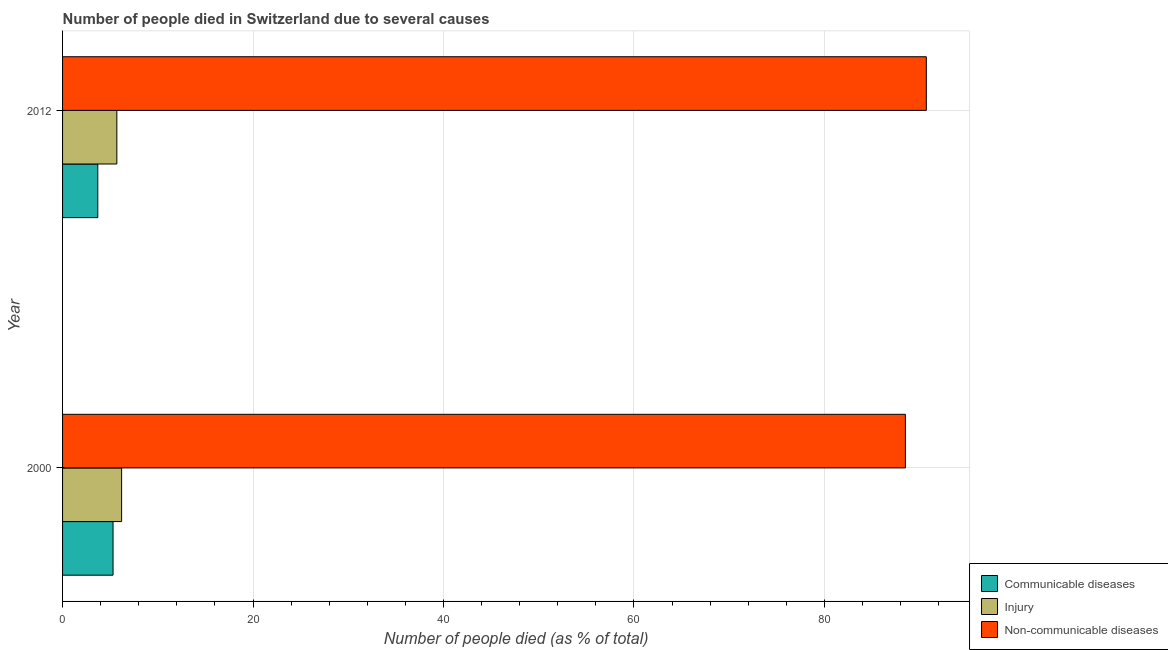How many groups of bars are there?
Provide a succinct answer. 2. How many bars are there on the 2nd tick from the bottom?
Provide a short and direct response. 3. What is the label of the 2nd group of bars from the top?
Offer a very short reply. 2000. Across all years, what is the maximum number of people who dies of non-communicable diseases?
Give a very brief answer. 90.7. Across all years, what is the minimum number of people who dies of non-communicable diseases?
Provide a succinct answer. 88.5. What is the total number of people who dies of non-communicable diseases in the graph?
Give a very brief answer. 179.2. What is the difference between the number of people who dies of non-communicable diseases in 2000 and the number of people who died of communicable diseases in 2012?
Give a very brief answer. 84.8. What is the average number of people who dies of non-communicable diseases per year?
Your response must be concise. 89.6. In the year 2012, what is the difference between the number of people who died of injury and number of people who dies of non-communicable diseases?
Your answer should be very brief. -85. In how many years, is the number of people who died of injury greater than 52 %?
Provide a succinct answer. 0. What is the ratio of the number of people who dies of non-communicable diseases in 2000 to that in 2012?
Offer a terse response. 0.98. What does the 1st bar from the top in 2012 represents?
Offer a very short reply. Non-communicable diseases. What does the 2nd bar from the bottom in 2000 represents?
Keep it short and to the point. Injury. Is it the case that in every year, the sum of the number of people who died of communicable diseases and number of people who died of injury is greater than the number of people who dies of non-communicable diseases?
Provide a short and direct response. No. How many bars are there?
Your answer should be compact. 6. Are all the bars in the graph horizontal?
Keep it short and to the point. Yes. How many years are there in the graph?
Provide a short and direct response. 2. What is the difference between two consecutive major ticks on the X-axis?
Offer a terse response. 20. Does the graph contain any zero values?
Offer a very short reply. No. Does the graph contain grids?
Ensure brevity in your answer.  Yes. How many legend labels are there?
Your answer should be very brief. 3. What is the title of the graph?
Ensure brevity in your answer.  Number of people died in Switzerland due to several causes. Does "Social Protection and Labor" appear as one of the legend labels in the graph?
Your response must be concise. No. What is the label or title of the X-axis?
Your response must be concise. Number of people died (as % of total). What is the label or title of the Y-axis?
Ensure brevity in your answer.  Year. What is the Number of people died (as % of total) of Communicable diseases in 2000?
Provide a short and direct response. 5.3. What is the Number of people died (as % of total) in Injury in 2000?
Keep it short and to the point. 6.2. What is the Number of people died (as % of total) in Non-communicable diseases in 2000?
Provide a short and direct response. 88.5. What is the Number of people died (as % of total) in Communicable diseases in 2012?
Ensure brevity in your answer.  3.7. What is the Number of people died (as % of total) of Non-communicable diseases in 2012?
Provide a short and direct response. 90.7. Across all years, what is the maximum Number of people died (as % of total) in Injury?
Make the answer very short. 6.2. Across all years, what is the maximum Number of people died (as % of total) of Non-communicable diseases?
Provide a short and direct response. 90.7. Across all years, what is the minimum Number of people died (as % of total) of Communicable diseases?
Your answer should be very brief. 3.7. Across all years, what is the minimum Number of people died (as % of total) of Injury?
Ensure brevity in your answer.  5.7. Across all years, what is the minimum Number of people died (as % of total) of Non-communicable diseases?
Give a very brief answer. 88.5. What is the total Number of people died (as % of total) of Non-communicable diseases in the graph?
Your answer should be very brief. 179.2. What is the difference between the Number of people died (as % of total) of Communicable diseases in 2000 and that in 2012?
Make the answer very short. 1.6. What is the difference between the Number of people died (as % of total) in Injury in 2000 and that in 2012?
Offer a very short reply. 0.5. What is the difference between the Number of people died (as % of total) in Communicable diseases in 2000 and the Number of people died (as % of total) in Non-communicable diseases in 2012?
Make the answer very short. -85.4. What is the difference between the Number of people died (as % of total) of Injury in 2000 and the Number of people died (as % of total) of Non-communicable diseases in 2012?
Offer a terse response. -84.5. What is the average Number of people died (as % of total) of Communicable diseases per year?
Your response must be concise. 4.5. What is the average Number of people died (as % of total) of Injury per year?
Offer a very short reply. 5.95. What is the average Number of people died (as % of total) of Non-communicable diseases per year?
Your answer should be compact. 89.6. In the year 2000, what is the difference between the Number of people died (as % of total) in Communicable diseases and Number of people died (as % of total) in Injury?
Offer a terse response. -0.9. In the year 2000, what is the difference between the Number of people died (as % of total) of Communicable diseases and Number of people died (as % of total) of Non-communicable diseases?
Offer a terse response. -83.2. In the year 2000, what is the difference between the Number of people died (as % of total) in Injury and Number of people died (as % of total) in Non-communicable diseases?
Offer a terse response. -82.3. In the year 2012, what is the difference between the Number of people died (as % of total) in Communicable diseases and Number of people died (as % of total) in Non-communicable diseases?
Your answer should be compact. -87. In the year 2012, what is the difference between the Number of people died (as % of total) of Injury and Number of people died (as % of total) of Non-communicable diseases?
Ensure brevity in your answer.  -85. What is the ratio of the Number of people died (as % of total) of Communicable diseases in 2000 to that in 2012?
Your answer should be very brief. 1.43. What is the ratio of the Number of people died (as % of total) in Injury in 2000 to that in 2012?
Provide a succinct answer. 1.09. What is the ratio of the Number of people died (as % of total) of Non-communicable diseases in 2000 to that in 2012?
Provide a short and direct response. 0.98. What is the difference between the highest and the second highest Number of people died (as % of total) of Injury?
Provide a succinct answer. 0.5. What is the difference between the highest and the lowest Number of people died (as % of total) of Non-communicable diseases?
Offer a very short reply. 2.2. 